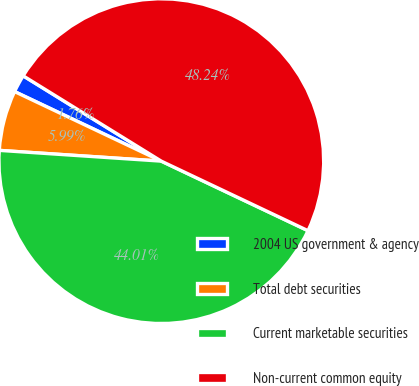Convert chart to OTSL. <chart><loc_0><loc_0><loc_500><loc_500><pie_chart><fcel>2004 US government & agency<fcel>Total debt securities<fcel>Current marketable securities<fcel>Non-current common equity<nl><fcel>1.76%<fcel>5.99%<fcel>44.01%<fcel>48.24%<nl></chart> 